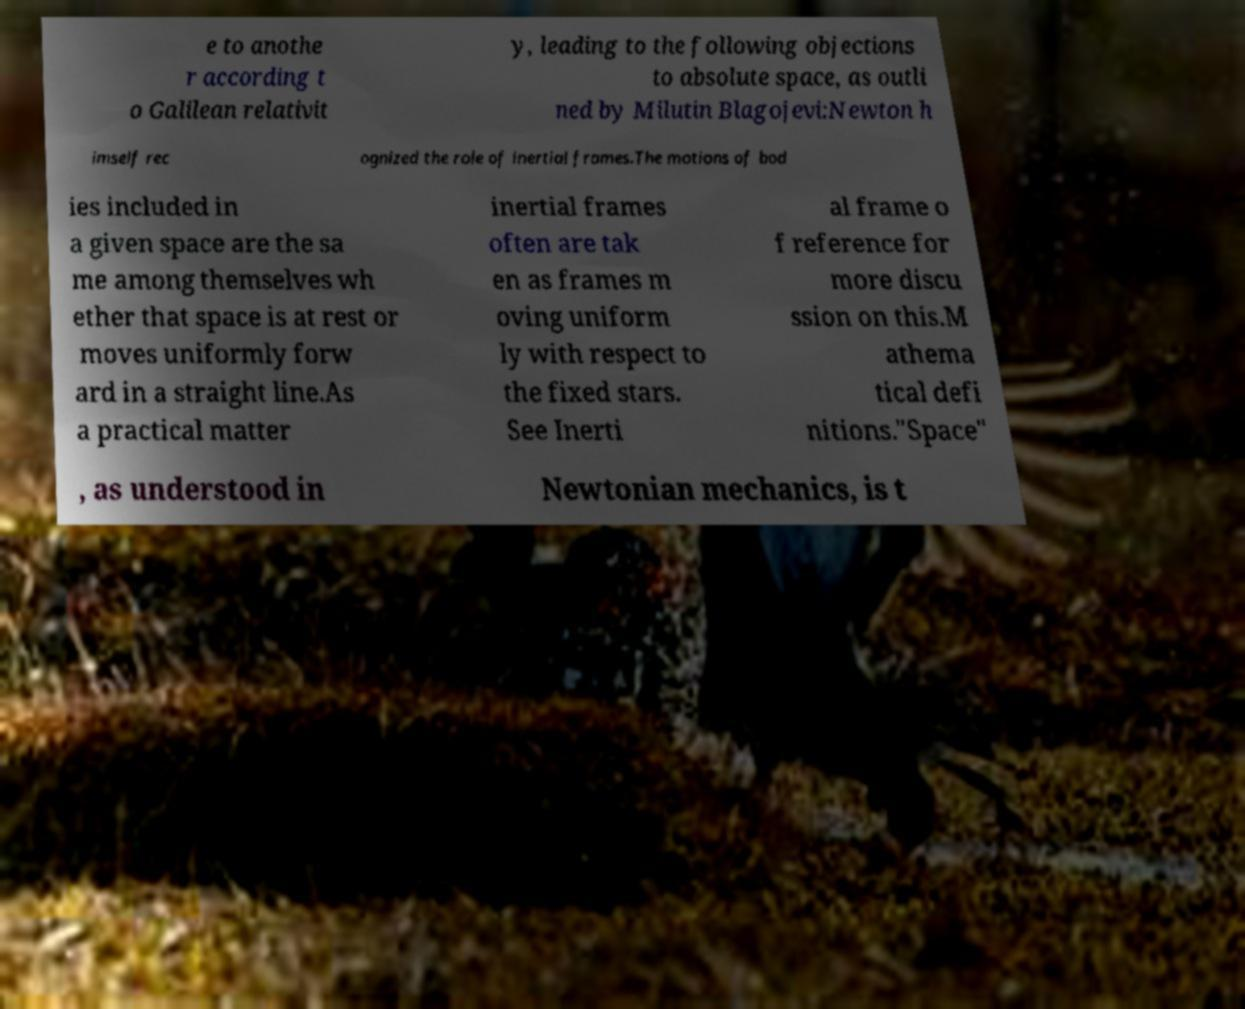Please identify and transcribe the text found in this image. e to anothe r according t o Galilean relativit y, leading to the following objections to absolute space, as outli ned by Milutin Blagojevi:Newton h imself rec ognized the role of inertial frames.The motions of bod ies included in a given space are the sa me among themselves wh ether that space is at rest or moves uniformly forw ard in a straight line.As a practical matter inertial frames often are tak en as frames m oving uniform ly with respect to the fixed stars. See Inerti al frame o f reference for more discu ssion on this.M athema tical defi nitions."Space" , as understood in Newtonian mechanics, is t 